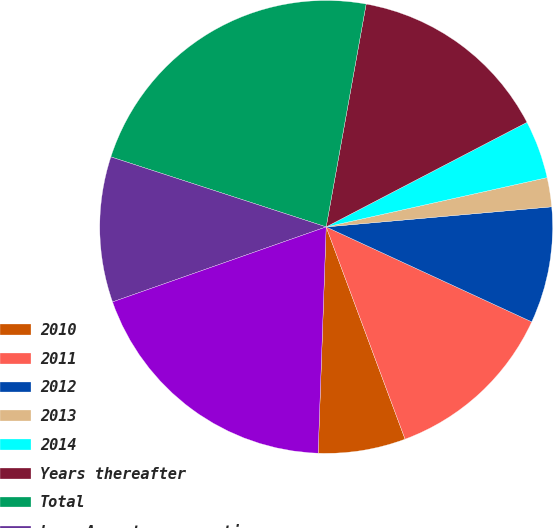<chart> <loc_0><loc_0><loc_500><loc_500><pie_chart><fcel>2010<fcel>2011<fcel>2012<fcel>2013<fcel>2014<fcel>Years thereafter<fcel>Total<fcel>Less Amount representing<fcel>Present value of net minimum<nl><fcel>6.23%<fcel>12.45%<fcel>8.3%<fcel>2.08%<fcel>4.15%<fcel>14.53%<fcel>22.82%<fcel>10.38%<fcel>19.06%<nl></chart> 